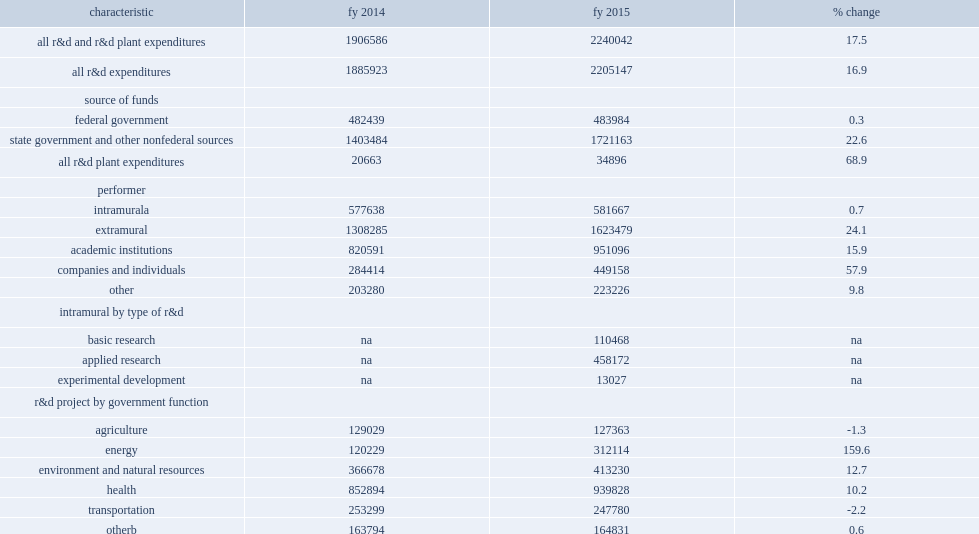How many percent did state government agency expenditures for research and development total in fy 2015? 2205147.0. State government agency expenditures for research and development totaled $2.2 billion in fy 2015, what was an increase from fy 2014? 16.9. 